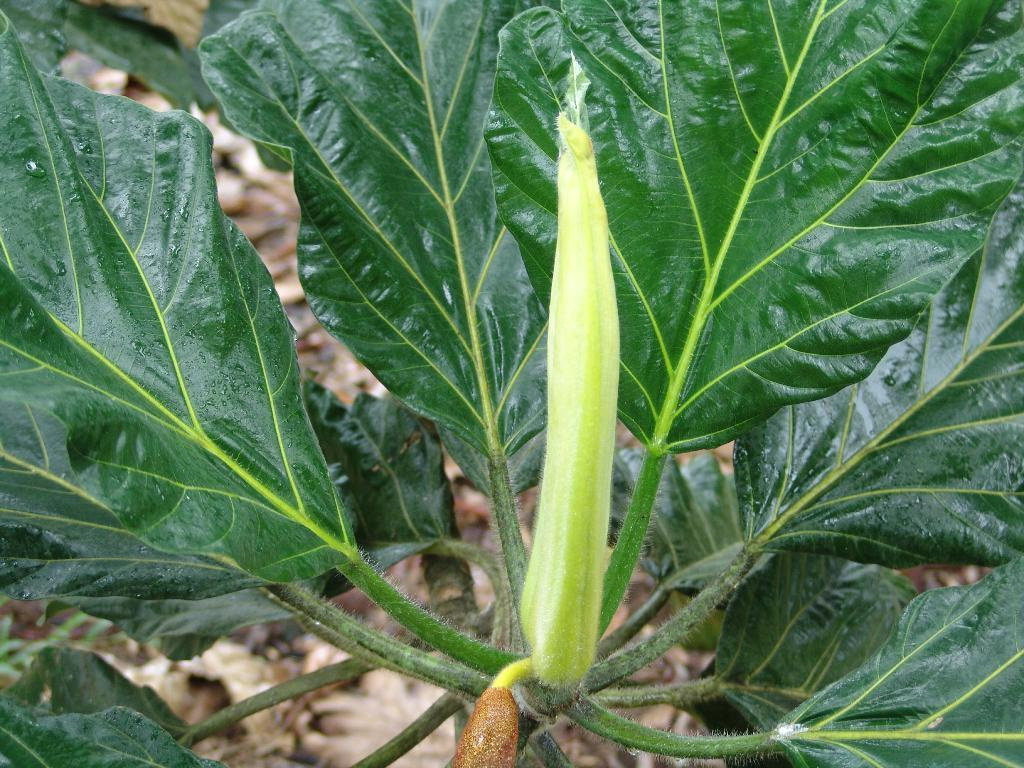What type of living organism can be seen in the image? There is a plant in the image. What type of blood can be seen dripping from the plant in the image? There is no blood present in the image, and the plant does not appear to be injured or bleeding. 